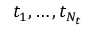<formula> <loc_0><loc_0><loc_500><loc_500>t _ { 1 } , \dots , t _ { N _ { t } }</formula> 